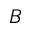Convert formula to latex. <formula><loc_0><loc_0><loc_500><loc_500>B</formula> 